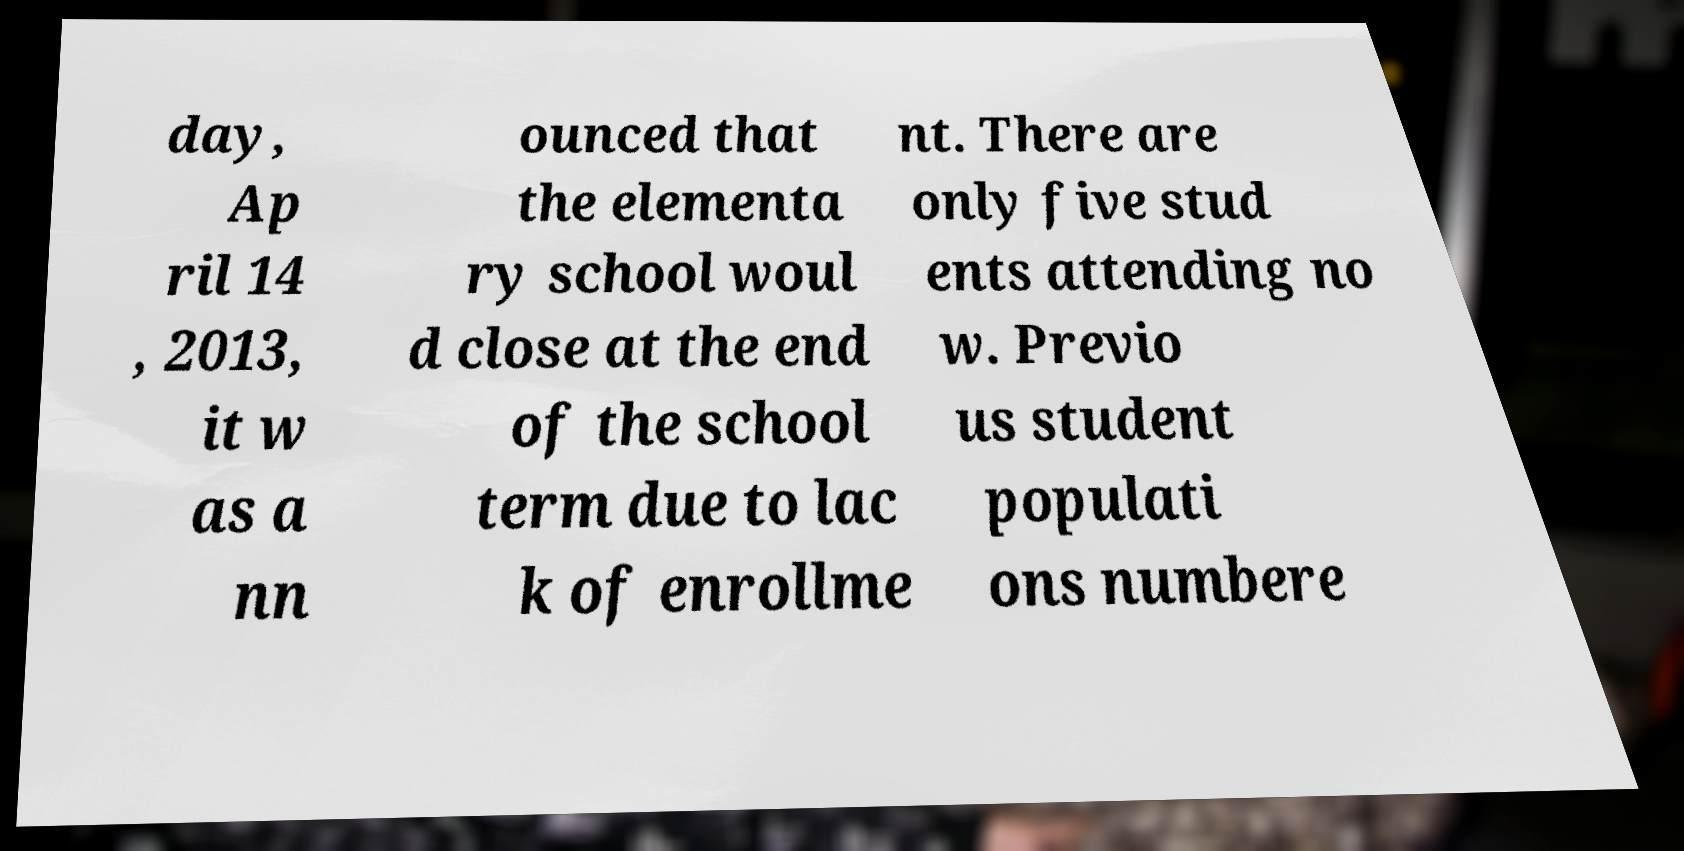Could you extract and type out the text from this image? day, Ap ril 14 , 2013, it w as a nn ounced that the elementa ry school woul d close at the end of the school term due to lac k of enrollme nt. There are only five stud ents attending no w. Previo us student populati ons numbere 